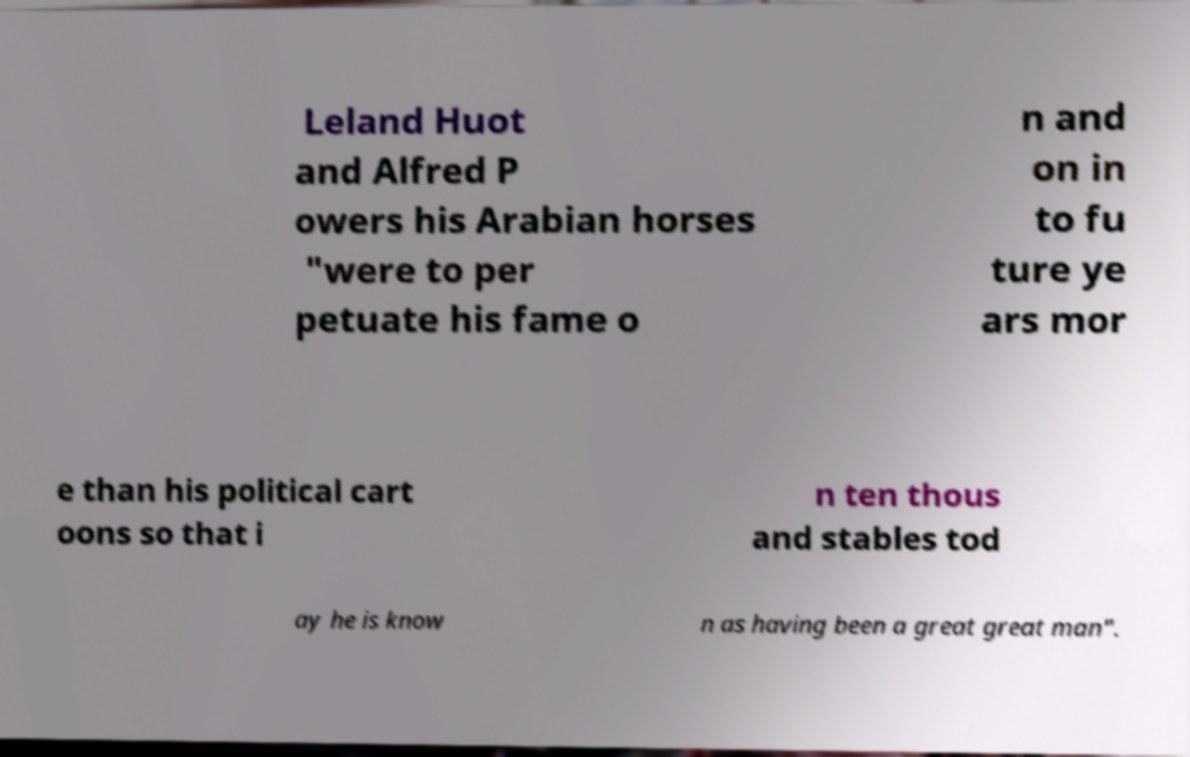Please identify and transcribe the text found in this image. Leland Huot and Alfred P owers his Arabian horses "were to per petuate his fame o n and on in to fu ture ye ars mor e than his political cart oons so that i n ten thous and stables tod ay he is know n as having been a great great man". 